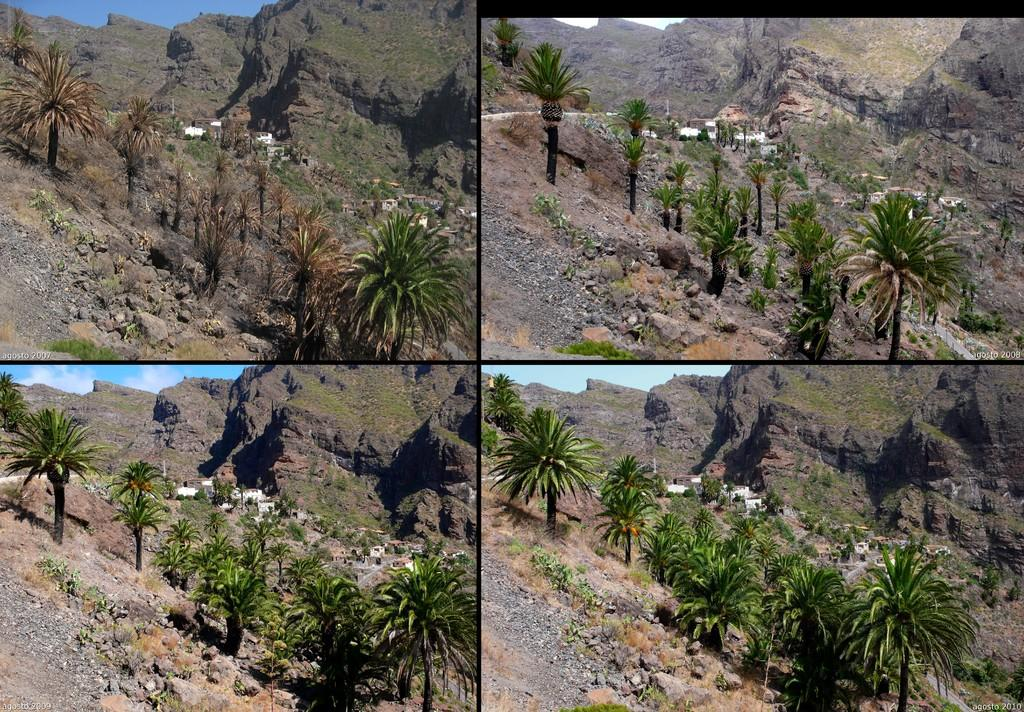What type of artwork is the image? The image is a collage. What type of natural landscape elements are present in the collage? There are hills, trees, and rocks in the collage. What type of man-made structures are present in the collage? There are buildings in the collage. What part of the natural environment is visible in the collage? The sky is visible in the collage. What type of pen can be seen in the image? There is no pen present in the image; it is a collage featuring hills, trees, rocks, buildings, and sky. How many tongues can be seen in the image? There are no tongues present in the image. 